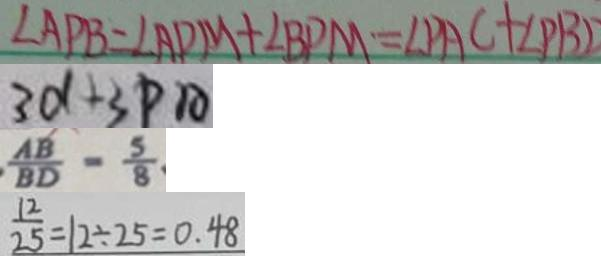<formula> <loc_0><loc_0><loc_500><loc_500>\angle A P B = \angle A D M + \angle B P M = \angle P A C + \angle P B D 
 3 d + 3 P A 
 \frac { A B } { B D } = \frac { 5 } { 8 } 
 \frac { 1 2 } { 2 5 } = 1 2 \div 2 5 = 0 . 4 8</formula> 